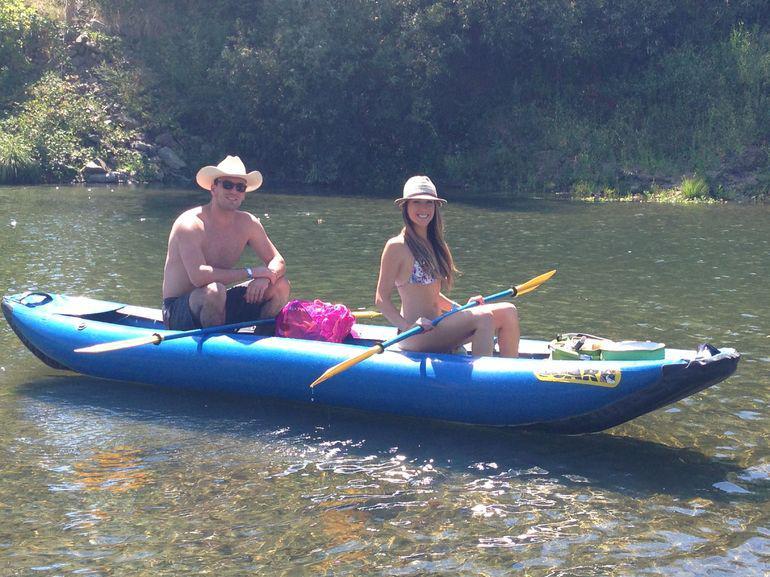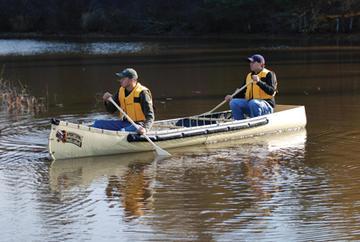The first image is the image on the left, the second image is the image on the right. Assess this claim about the two images: "There is at most 1 dog in a canoe.". Correct or not? Answer yes or no. No. The first image is the image on the left, the second image is the image on the right. For the images displayed, is the sentence "None of the boats are blue." factually correct? Answer yes or no. No. 